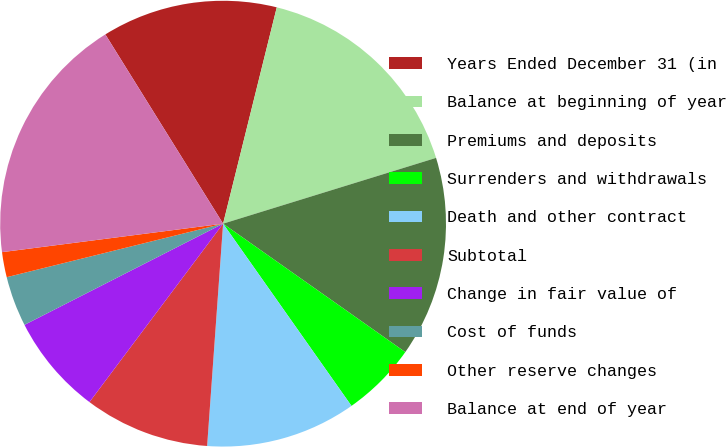<chart> <loc_0><loc_0><loc_500><loc_500><pie_chart><fcel>Years Ended December 31 (in<fcel>Balance at beginning of year<fcel>Premiums and deposits<fcel>Surrenders and withdrawals<fcel>Death and other contract<fcel>Subtotal<fcel>Change in fair value of<fcel>Cost of funds<fcel>Other reserve changes<fcel>Balance at end of year<nl><fcel>12.73%<fcel>16.36%<fcel>14.54%<fcel>5.46%<fcel>10.91%<fcel>9.09%<fcel>7.27%<fcel>3.64%<fcel>1.82%<fcel>18.18%<nl></chart> 